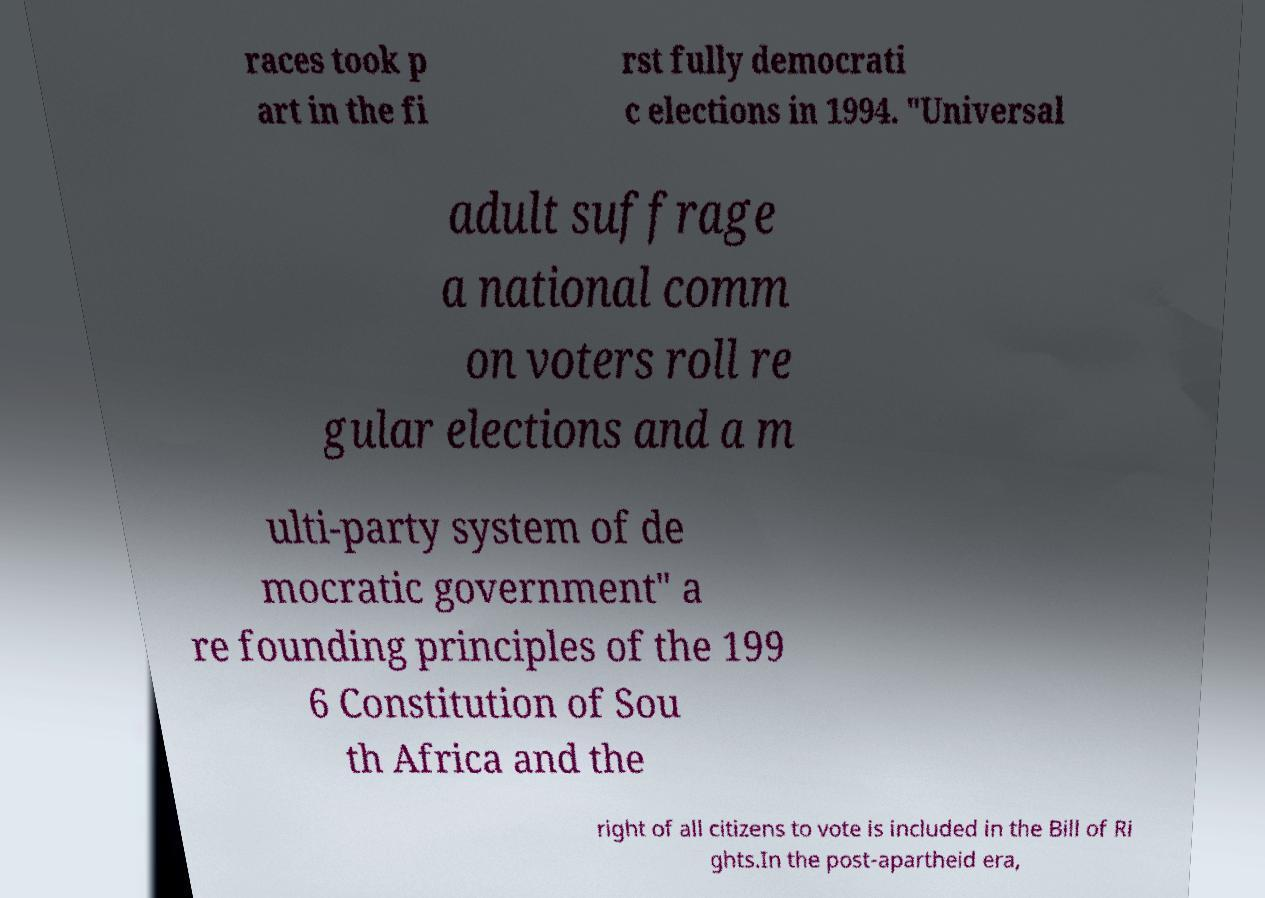Please identify and transcribe the text found in this image. races took p art in the fi rst fully democrati c elections in 1994. "Universal adult suffrage a national comm on voters roll re gular elections and a m ulti-party system of de mocratic government" a re founding principles of the 199 6 Constitution of Sou th Africa and the right of all citizens to vote is included in the Bill of Ri ghts.In the post-apartheid era, 